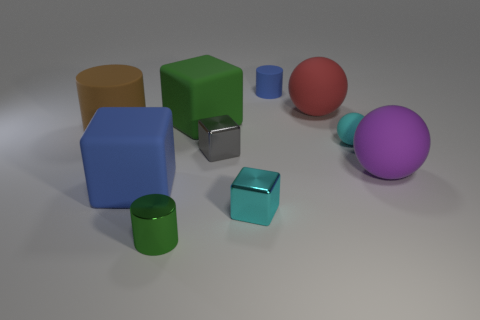Do the brown thing and the blue cylinder have the same size?
Make the answer very short. No. What number of big objects are cyan metal cubes or cyan matte things?
Offer a terse response. 0. There is a green shiny cylinder; how many big brown matte objects are behind it?
Offer a terse response. 1. Are there more big blue matte blocks that are behind the purple ball than rubber things?
Offer a very short reply. No. There is a large blue thing that is the same material as the red ball; what is its shape?
Provide a succinct answer. Cube. There is a matte cylinder that is in front of the small rubber object that is behind the large green cube; what color is it?
Offer a very short reply. Brown. Does the big purple thing have the same shape as the small cyan rubber object?
Keep it short and to the point. Yes. What is the material of the big blue object that is the same shape as the small gray shiny thing?
Give a very brief answer. Rubber. Are there any metallic blocks on the left side of the matte cylinder in front of the small cylinder that is behind the big purple object?
Provide a succinct answer. No. There is a gray object; is it the same shape as the tiny rubber object behind the big brown thing?
Keep it short and to the point. No. 